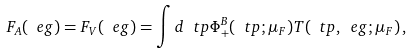Convert formula to latex. <formula><loc_0><loc_0><loc_500><loc_500>F _ { A } ( \ e g ) = F _ { V } ( \ e g ) = \int d \ t p \Phi _ { + } ^ { B } ( \ t p ; \mu _ { F } ) T ( \ t p , \ e g ; \mu _ { F } ) \, ,</formula> 